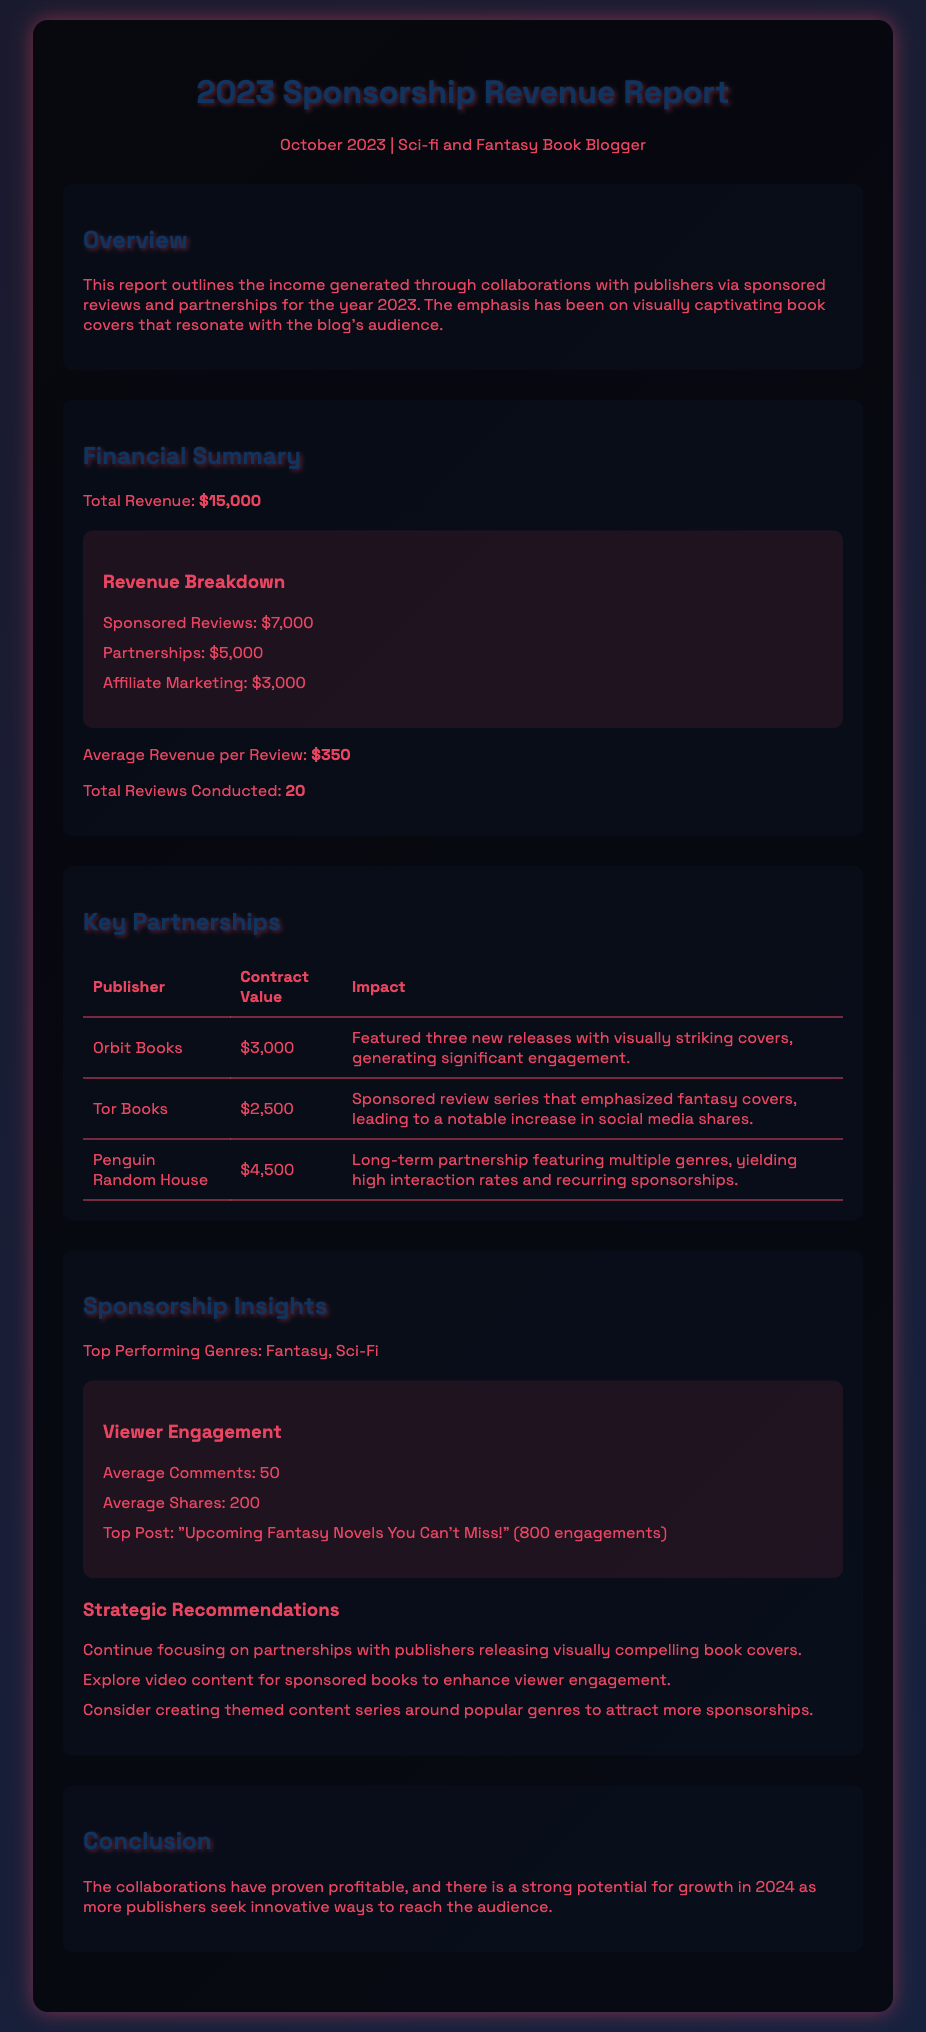What is the total revenue? The total revenue is directly stated in the Financial Summary section of the document.
Answer: $15,000 How much was earned from sponsored reviews? The revenue from sponsored reviews is listed in the Revenue Breakdown of the Financial Summary.
Answer: $7,000 What was the contract value with Penguin Random House? The contract values for the partnerships are detailed in the Key Partnerships table.
Answer: $4,500 How many total reviews were conducted? The total number of reviews is specified in the Financial Summary section.
Answer: 20 What is the average revenue per review? The average revenue per review is mentioned in the Financial Summary.
Answer: $350 Which publisher had a contract value of $3,000? The Key Partnerships table specifies the contract values alongside the publishers' names.
Answer: Orbit Books What was the top performing genre? The top performing genres are highlighted in the Sponsorship Insights section.
Answer: Fantasy What was the top post's engagement figure? The engagement details for the top post are provided under Viewer Engagement in the Sponsorship Insights section.
Answer: 800 engagements What strategic recommendation involves video content? One of the strategic recommendations discusses enhancing viewer engagement through video content.
Answer: Explore video content for sponsored books 